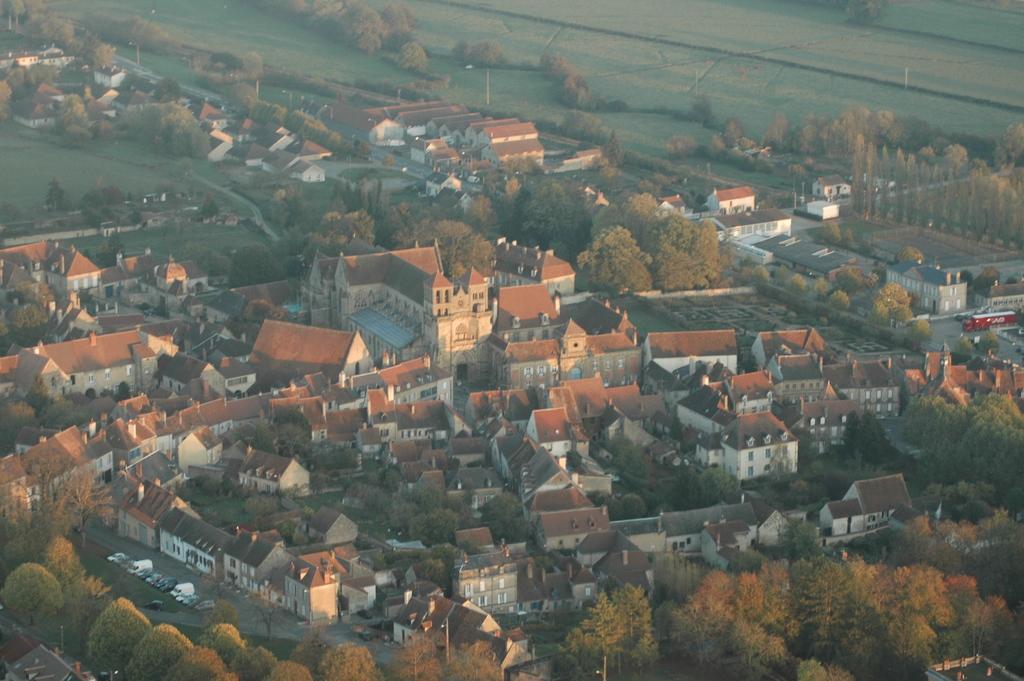Could you give a brief overview of what you see in this image? The image is captured far away from the city. There are plenty of trees and houses in the city and on the city outskirts there is a beautiful greenery. 